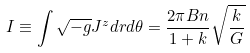<formula> <loc_0><loc_0><loc_500><loc_500>I \equiv \int \sqrt { - g } J ^ { z } d r d \theta = \frac { 2 \pi B n } { 1 + k } \sqrt { \frac { k } { G } }</formula> 